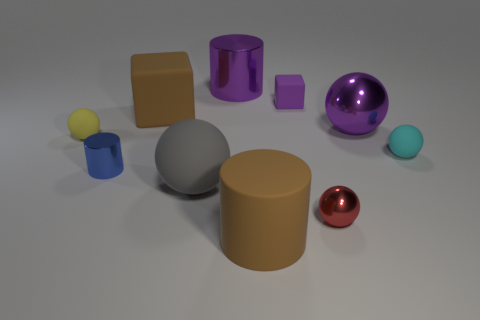Can you tell me what the large purple object is made of and why it appears shiny? The large purple object appears to be made of a highly reflective material, such as polished metal or glass, which is why it has a shiny surface. The light reflects off it in a way that is characteristic of such materials, creating a clear specular highlight. 